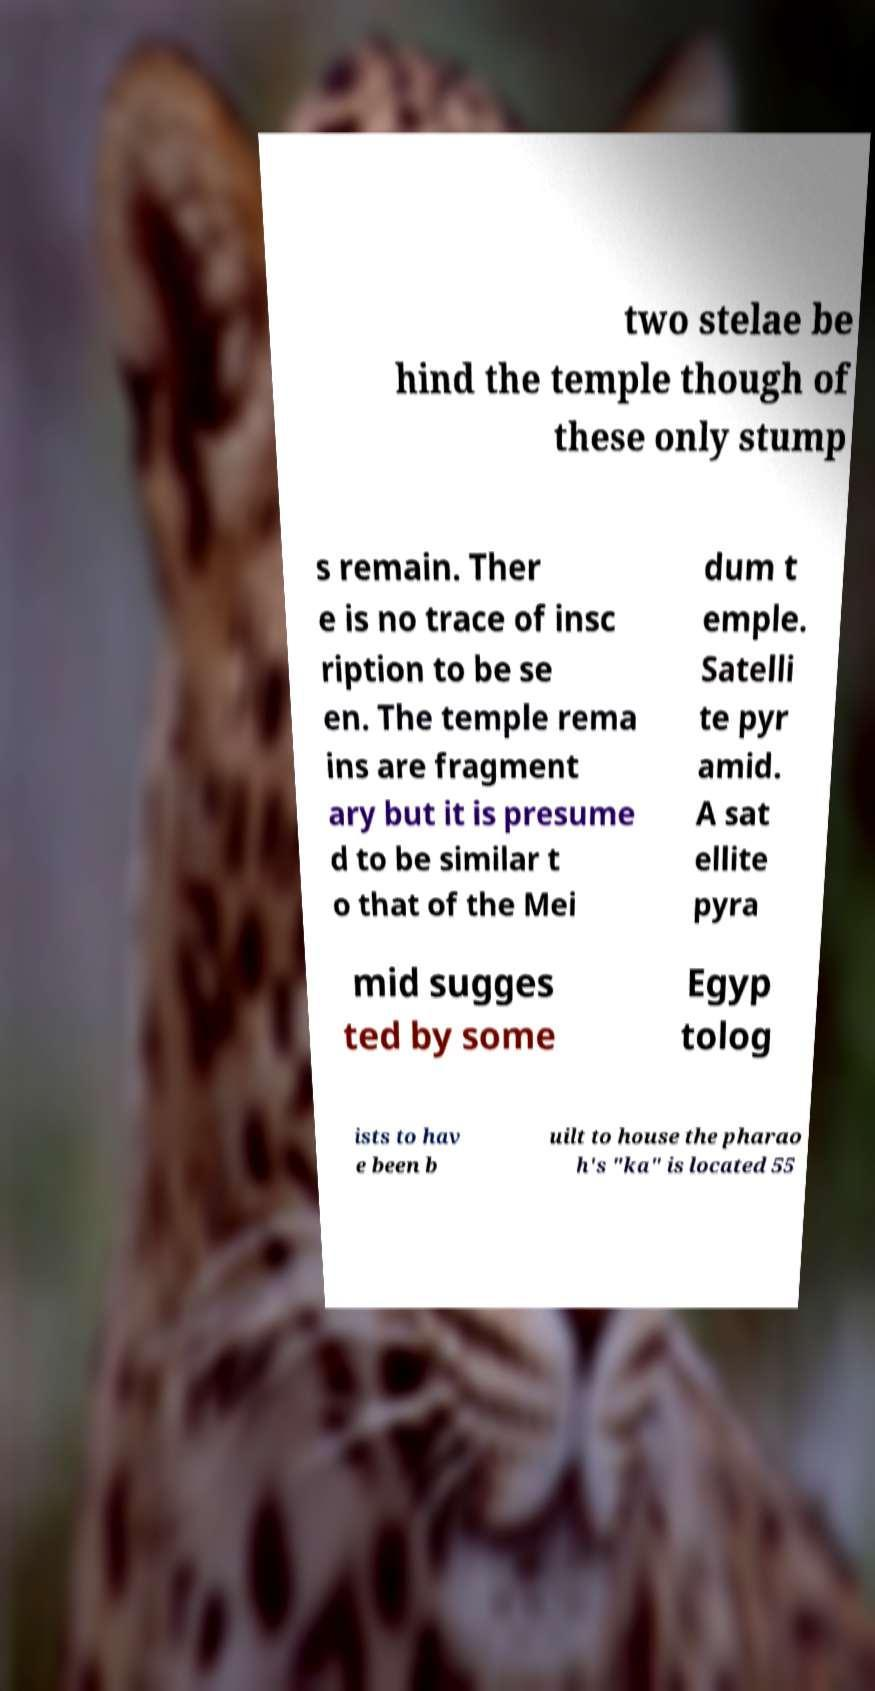Can you read and provide the text displayed in the image?This photo seems to have some interesting text. Can you extract and type it out for me? two stelae be hind the temple though of these only stump s remain. Ther e is no trace of insc ription to be se en. The temple rema ins are fragment ary but it is presume d to be similar t o that of the Mei dum t emple. Satelli te pyr amid. A sat ellite pyra mid sugges ted by some Egyp tolog ists to hav e been b uilt to house the pharao h's "ka" is located 55 